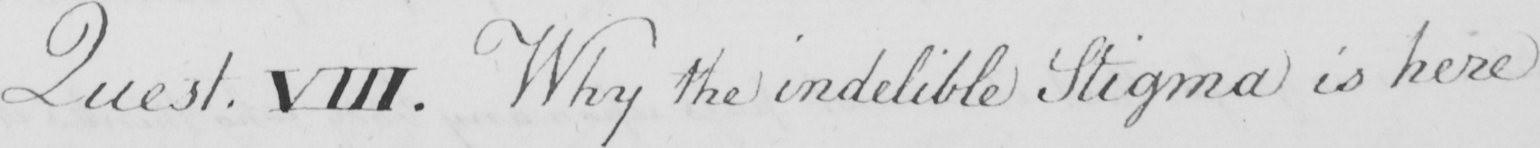Please transcribe the handwritten text in this image. Quest . VIII . Why the indelible Stigma is here 